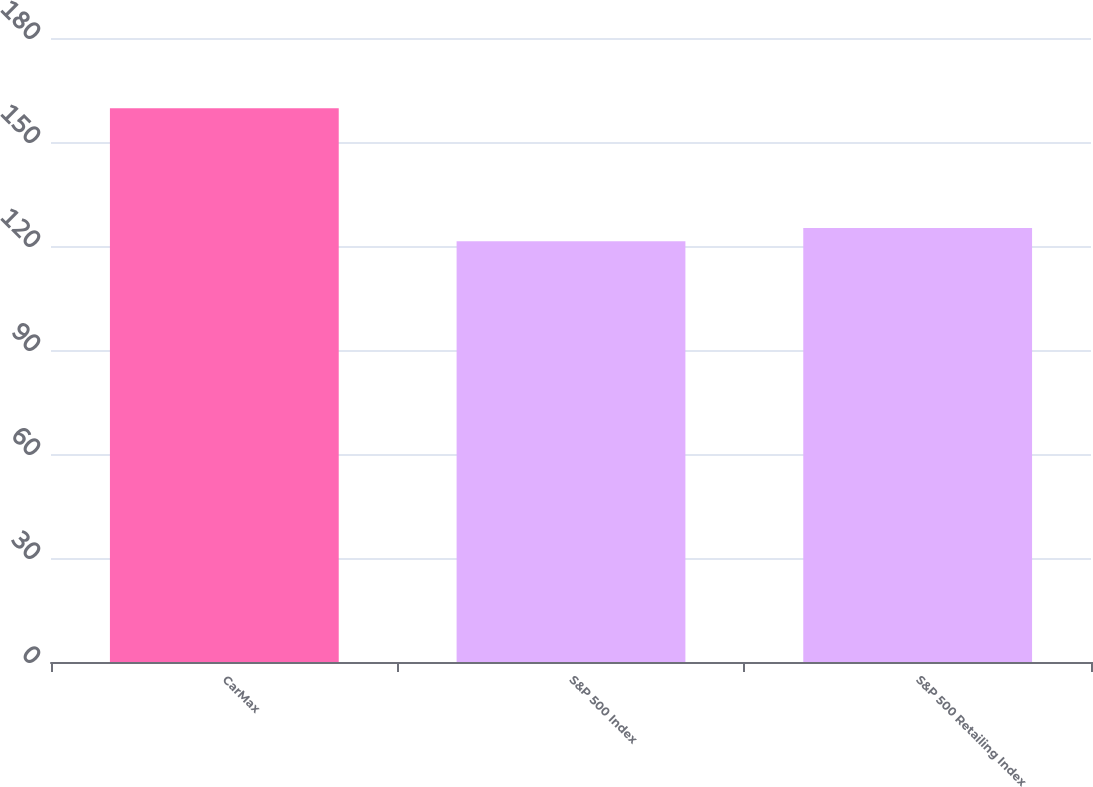<chart> <loc_0><loc_0><loc_500><loc_500><bar_chart><fcel>CarMax<fcel>S&P 500 Index<fcel>S&P 500 Retailing Index<nl><fcel>159.7<fcel>121.38<fcel>125.21<nl></chart> 